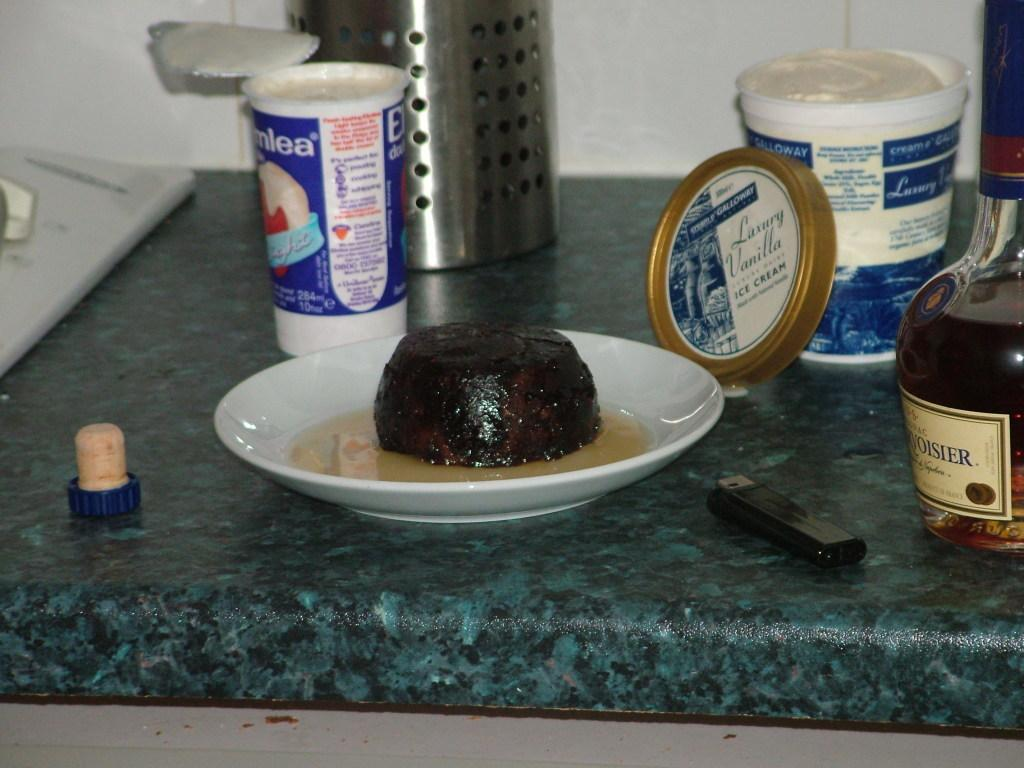<image>
Describe the image concisely. Piece of food on a plate next to a container that says "ICE CREAM". 